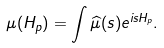Convert formula to latex. <formula><loc_0><loc_0><loc_500><loc_500>\mu ( H _ { p } ) = \int \widehat { \mu } ( s ) e ^ { i s H _ { p } } .</formula> 